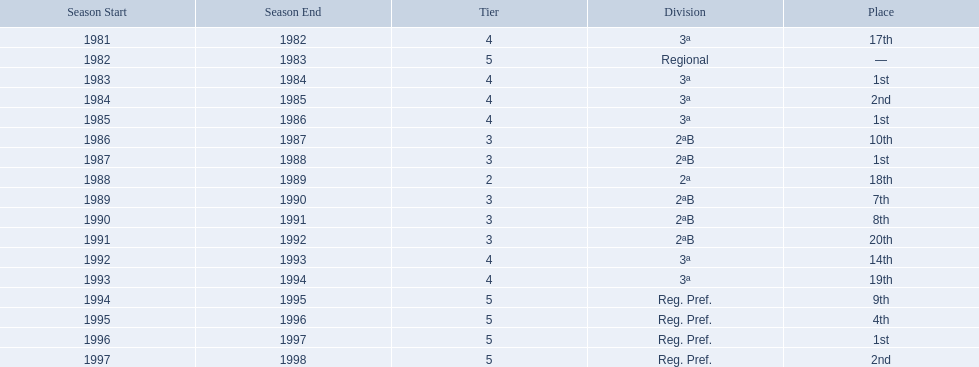In what years did the team finish 17th or worse? 1981/82, 1988/89, 1991/92, 1993/94. Of those, in which year the team finish worse? 1991/92. 